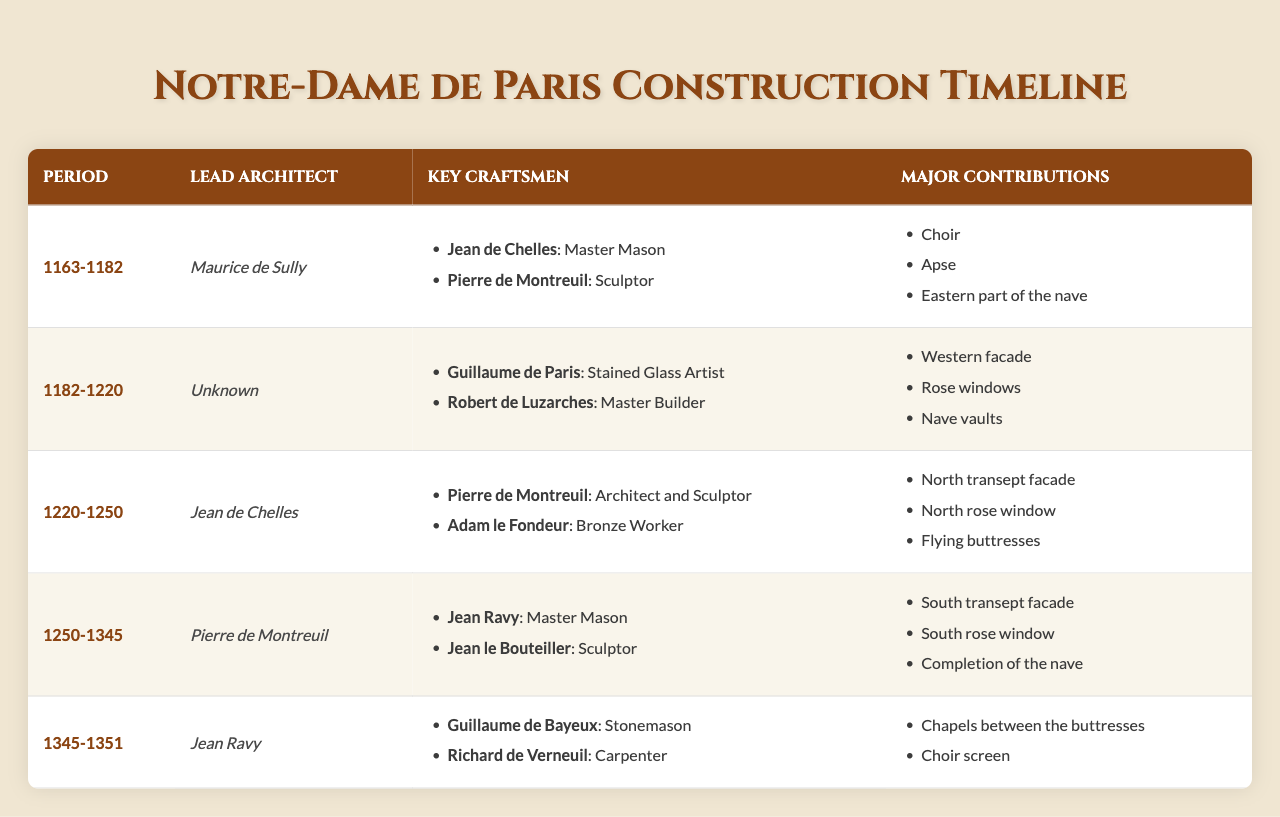What period did Maurice de Sully lead the construction of Notre-Dame de Paris? Maurice de Sully is listed as the Lead Architect for the period from 1163 to 1182 in the table.
Answer: 1163-1182 Which craftsman specialized in stained glass during the construction of Notre-Dame de Paris? The table lists Guillaume de Paris as the stained glass artist during the period of 1182-1220.
Answer: Guillaume de Paris What were the major contributions during the period of 1250-1345? The table shows that during the period of 1250-1345, the major contributions included the south transept facade, south rose window, and completion of the nave.
Answer: South transept facade, south rose window, completion of the nave Did Jean de Chelles contribute to the construction of the north rose window? Yes, Jean de Chelles is noted as the Lead Architect during the period from 1220-1250, when the north rose window was a major contribution.
Answer: Yes List the key craftsmen for the period 1345-1351. According to the table, the key craftsmen for the period 1345-1351 were Guillaume de Bayeux (Stonemason) and Richard de Verneuil (Carpenter).
Answer: Guillaume de Bayeux, Richard de Verneuil Which architect was responsible for the major contributions during the earliest period listed, 1163-1182? The Lead Architect responsible for the contributions during the period of 1163-1182 was Maurice de Sully, as per the table.
Answer: Maurice de Sully How many different architects are mentioned in the table? The table includes four different architects: Maurice de Sully, Jean de Chelles, Pierre de Montreuil, and Jean Ravy. Therefore, the count is 4.
Answer: 4 What is the period with the most contributions listed? Analyzing the table, the periods around 1250-1345 have three major contributions listed, which is more than others.
Answer: 1250-1345 Did any architect lead the construction during the period 1182-1220? The table indicates that the Lead Architect for the period 1182-1220 is listed as "Unknown," meaning no specific person was credited.
Answer: No What were the specialties of the key craftsmen during 1345-1351? The key craftsmen's specialties during 1345-1351 included stonemasonry by Guillaume de Bayeux and carpentry by Richard de Verneuil.
Answer: Stonemason, Carpenter 